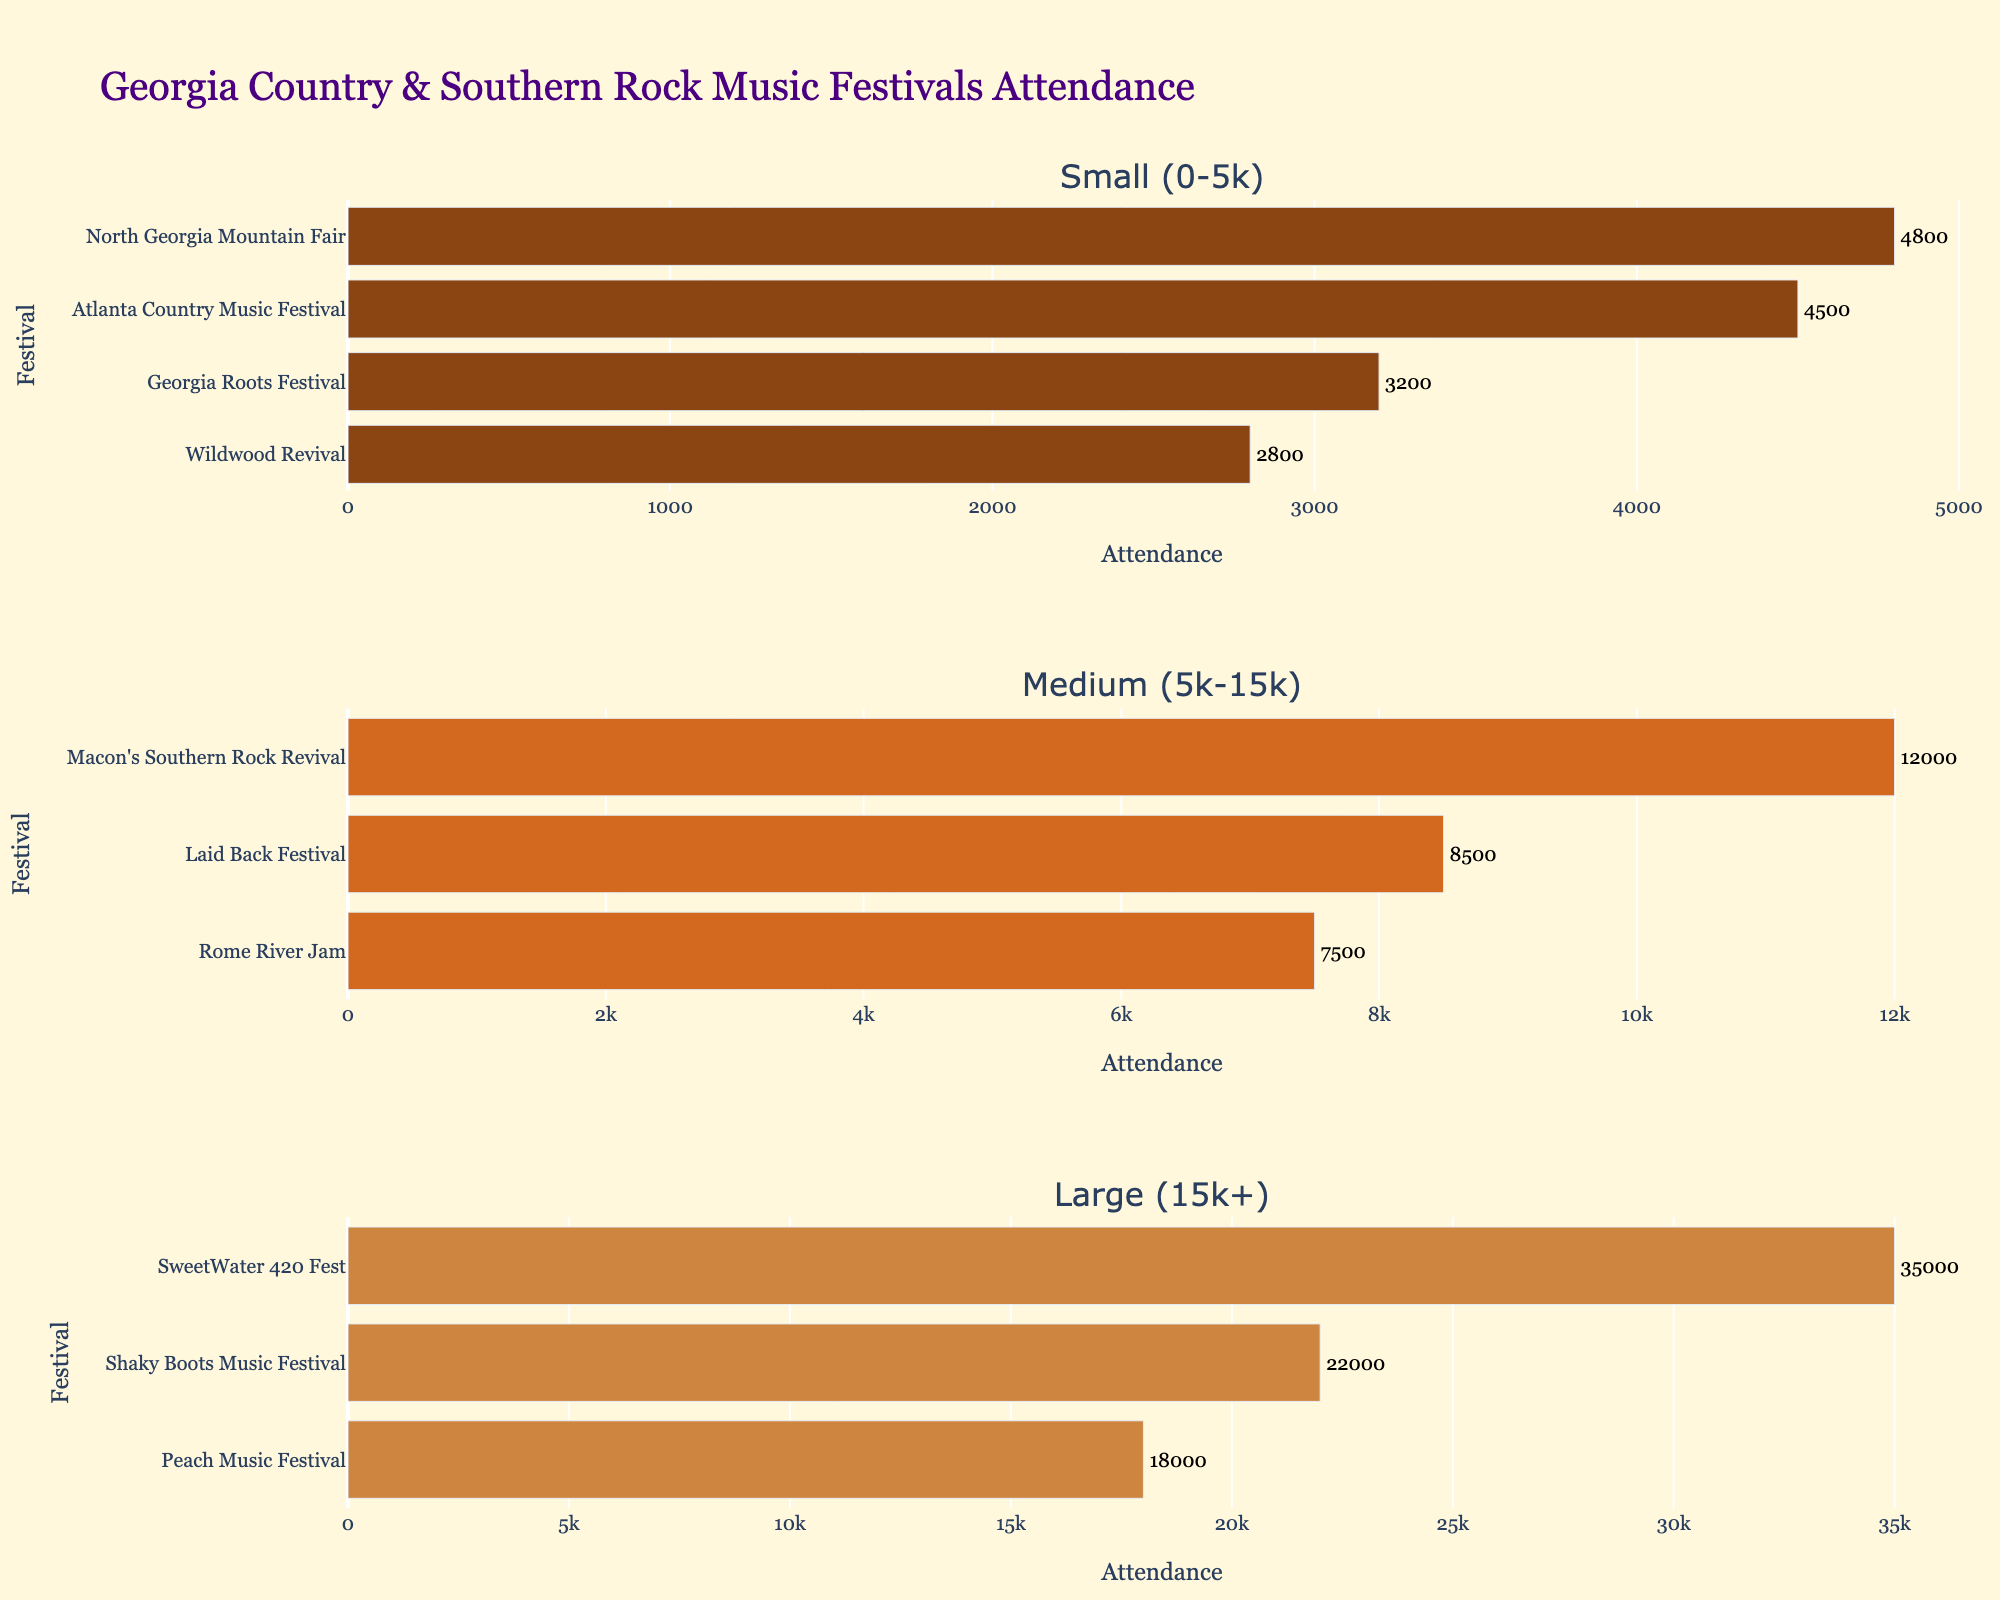What's the title of the figure? The title is typically displayed at the top of the figure in a larger font to succinctly describe the content.
Answer: Georgia Country & Southern Rock Music Festivals Attendance How many subplots are there in the figure? The figure consists of separate horizontal bar charts stacked vertically, known as subplots. The total number of individual charts was counted.
Answer: 3 Which festival has the highest attendance in the 'Small (0-5k)' category? To find this, we look at the 'Small (0-5k)' subplot and identify the festival with the longest bar and its associated label.
Answer: North Georgia Mountain Fair What is the sum of the attendance figures for all festivals in the 'Large (15k+)' category? Locate each attendance figure listed in the 'Large (15k+)' subplot, and sum them up: 22000 (Shaky Boots Music Festival) + 35000 (SweetWater 420 Fest) + 18000 (Peach Music Festival).
Answer: 75000 How does the attendance of Laid Back Festival compare with that of Rome River Jam? Find the two festivals in the 'Medium (5k-15k)' subplot and compare their attendance figures to see which one is greater.
Answer: Laid Back Festival has a higher attendance than Rome River Jam Which subplots display data using shades of brown? The subplots use different shades of brown for bars representing different attendance categories. Identify these colors by looking at the bars in each subplot.
Answer: All three subplots How many festivals fall under the 'Medium (5k-15k)' category? Count the number of different festivals present in the 'Medium (5k-15k)' subplot based on their bar representations and labels.
Answer: 3 What's the difference in attendance between Wildwood Revival and Atlanta Country Music Festival? Find the attendance figures for both festivals in the 'Small (0-5k)' subplot and calculate the difference: 4500 (Atlanta Country Music Festival) - 2800 (Wildwood Revival).
Answer: 1700 Which festival has 12,000 attendees, and in which category does it fall? In the 'Medium (5k-15k)' subplot, identify the festival with a bar reaching 12,000 and note its category.
Answer: Macon's Southern Rock Revival, Medium (5k-15k) What is the average attendance for festivals in the 'Large (15k+)' category? To find this, sum the attendance figures in the 'Large (15k+)' subplot (22000 + 35000 + 18000) and then divide by the number of festivals (3).
Answer: 25000 